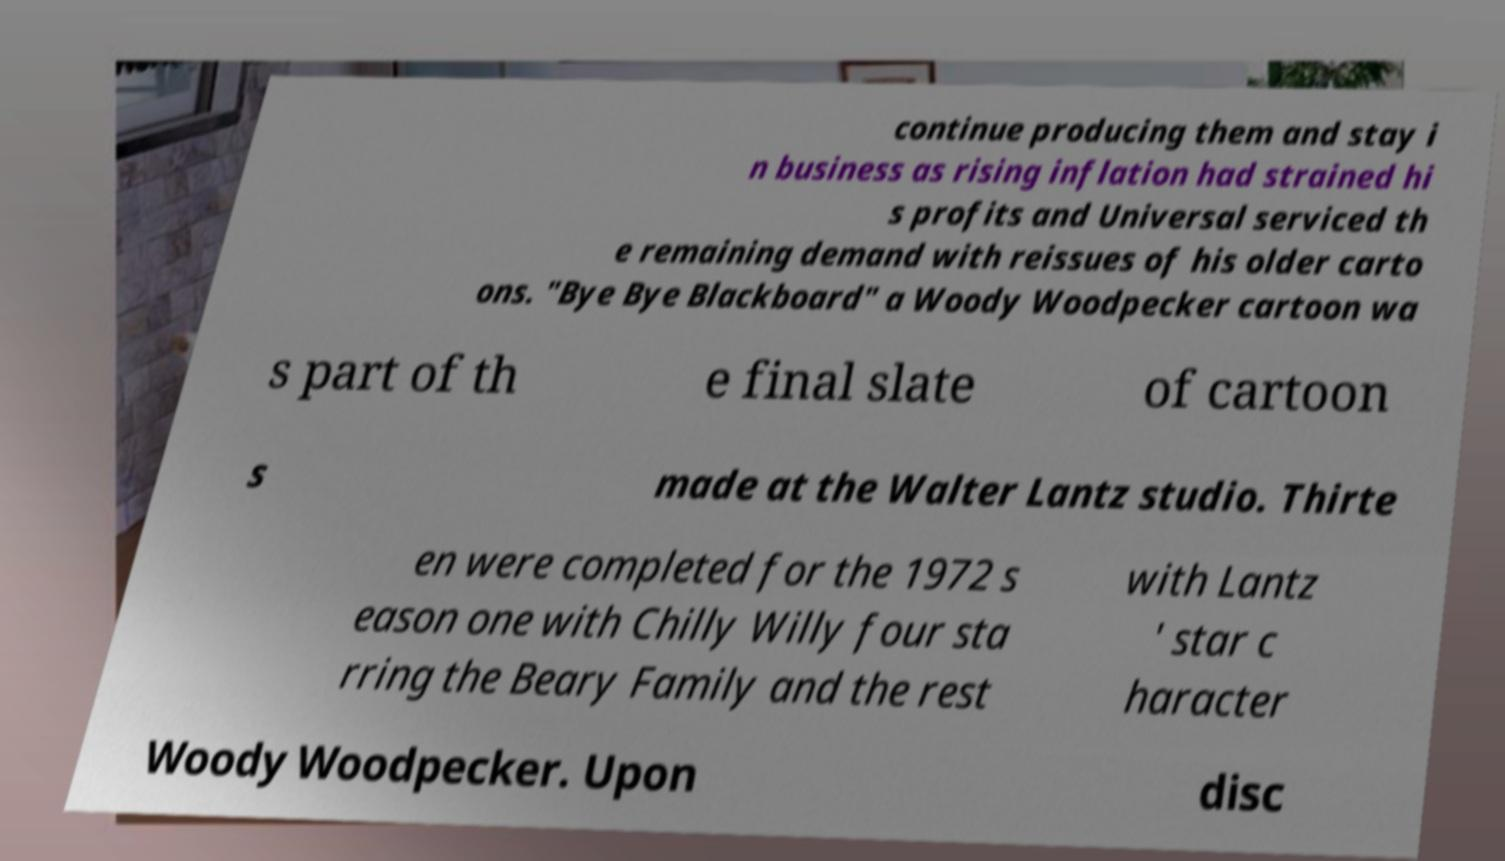Please identify and transcribe the text found in this image. continue producing them and stay i n business as rising inflation had strained hi s profits and Universal serviced th e remaining demand with reissues of his older carto ons. "Bye Bye Blackboard" a Woody Woodpecker cartoon wa s part of th e final slate of cartoon s made at the Walter Lantz studio. Thirte en were completed for the 1972 s eason one with Chilly Willy four sta rring the Beary Family and the rest with Lantz ' star c haracter Woody Woodpecker. Upon disc 